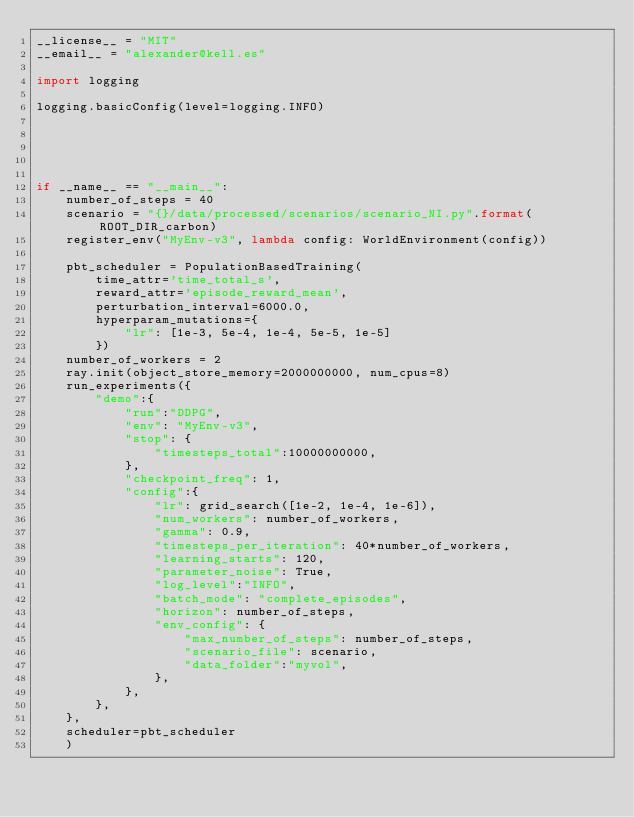<code> <loc_0><loc_0><loc_500><loc_500><_Python_>__license__ = "MIT"
__email__ = "alexander@kell.es"

import logging

logging.basicConfig(level=logging.INFO)





if __name__ == "__main__":
    number_of_steps = 40
    scenario = "{}/data/processed/scenarios/scenario_NI.py".format(ROOT_DIR_carbon)
    register_env("MyEnv-v3", lambda config: WorldEnvironment(config))

    pbt_scheduler = PopulationBasedTraining(
        time_attr='time_total_s',
        reward_attr='episode_reward_mean',
        perturbation_interval=6000.0,
        hyperparam_mutations={
            "lr": [1e-3, 5e-4, 1e-4, 5e-5, 1e-5]
        })
    number_of_workers = 2
    ray.init(object_store_memory=2000000000, num_cpus=8)
    run_experiments({
        "demo":{
            "run":"DDPG",
            "env": "MyEnv-v3",
            "stop": {
                "timesteps_total":10000000000,
            },
            "checkpoint_freq": 1,
            "config":{
                "lr": grid_search([1e-2, 1e-4, 1e-6]),
                "num_workers": number_of_workers,
                "gamma": 0.9,
                "timesteps_per_iteration": 40*number_of_workers,
                "learning_starts": 120,
                "parameter_noise": True,
                "log_level":"INFO",
                "batch_mode": "complete_episodes",
                "horizon": number_of_steps,
                "env_config": {
                    "max_number_of_steps": number_of_steps,
                    "scenario_file": scenario,
                    "data_folder":"myvol",
                },
            },
        },
    },
    scheduler=pbt_scheduler
    )</code> 